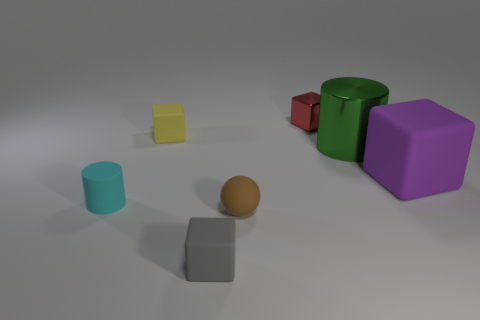There is a cylinder that is on the left side of the rubber sphere; what is it made of?
Your answer should be very brief. Rubber. Do the green metallic cylinder and the purple matte cube have the same size?
Give a very brief answer. Yes. What is the color of the rubber cube that is both on the left side of the green shiny cylinder and behind the brown sphere?
Make the answer very short. Yellow. There is a large purple thing that is made of the same material as the tiny sphere; what shape is it?
Offer a very short reply. Cube. How many cylinders are behind the purple object and left of the red thing?
Offer a terse response. 0. Are there any tiny brown balls right of the small gray matte thing?
Provide a short and direct response. Yes. Do the matte thing behind the large matte thing and the metal thing that is in front of the small red thing have the same shape?
Make the answer very short. No. How many things are blue metallic things or blocks that are behind the cyan matte cylinder?
Your answer should be very brief. 3. What number of other objects are there of the same shape as the large metallic object?
Provide a succinct answer. 1. Does the cylinder left of the small metal thing have the same material as the big green cylinder?
Make the answer very short. No. 